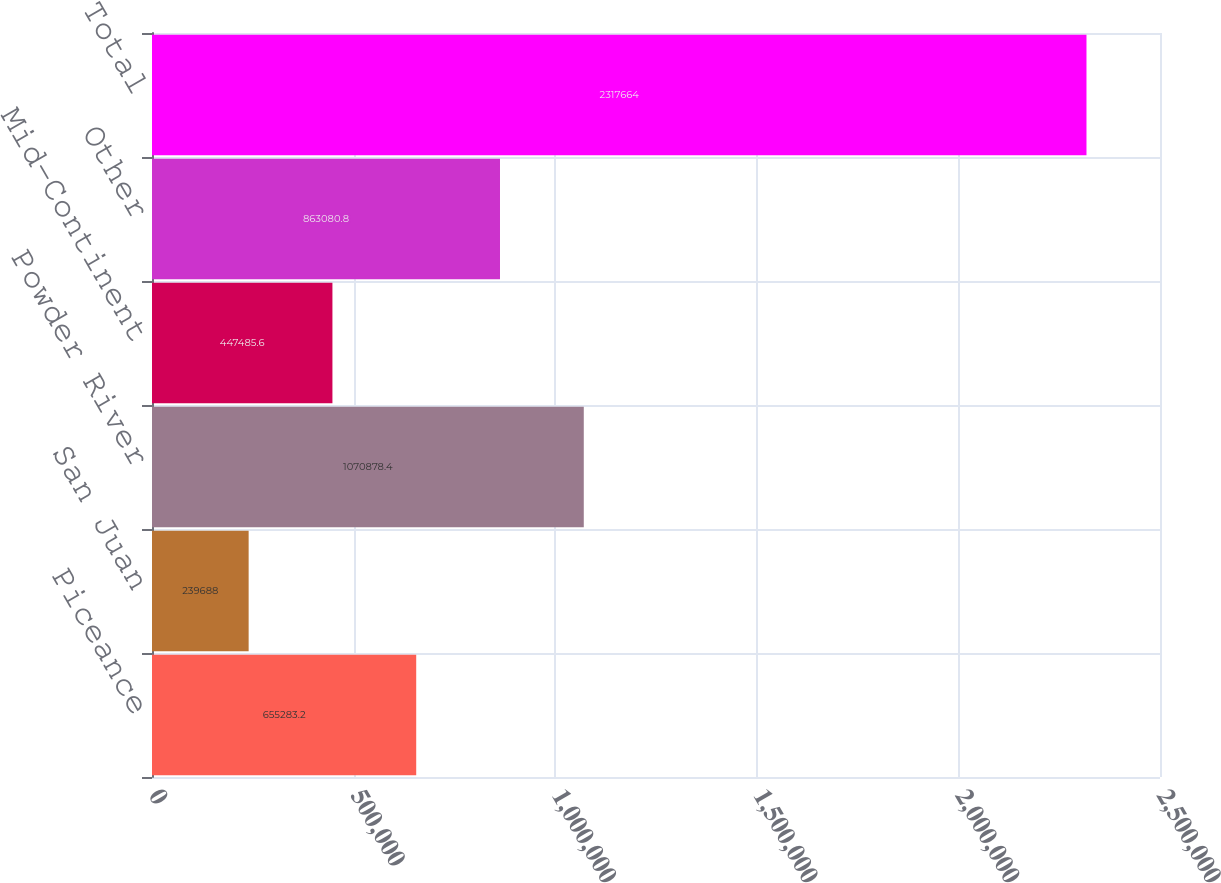<chart> <loc_0><loc_0><loc_500><loc_500><bar_chart><fcel>Piceance<fcel>San Juan<fcel>Powder River<fcel>Mid-Continent<fcel>Other<fcel>Total<nl><fcel>655283<fcel>239688<fcel>1.07088e+06<fcel>447486<fcel>863081<fcel>2.31766e+06<nl></chart> 